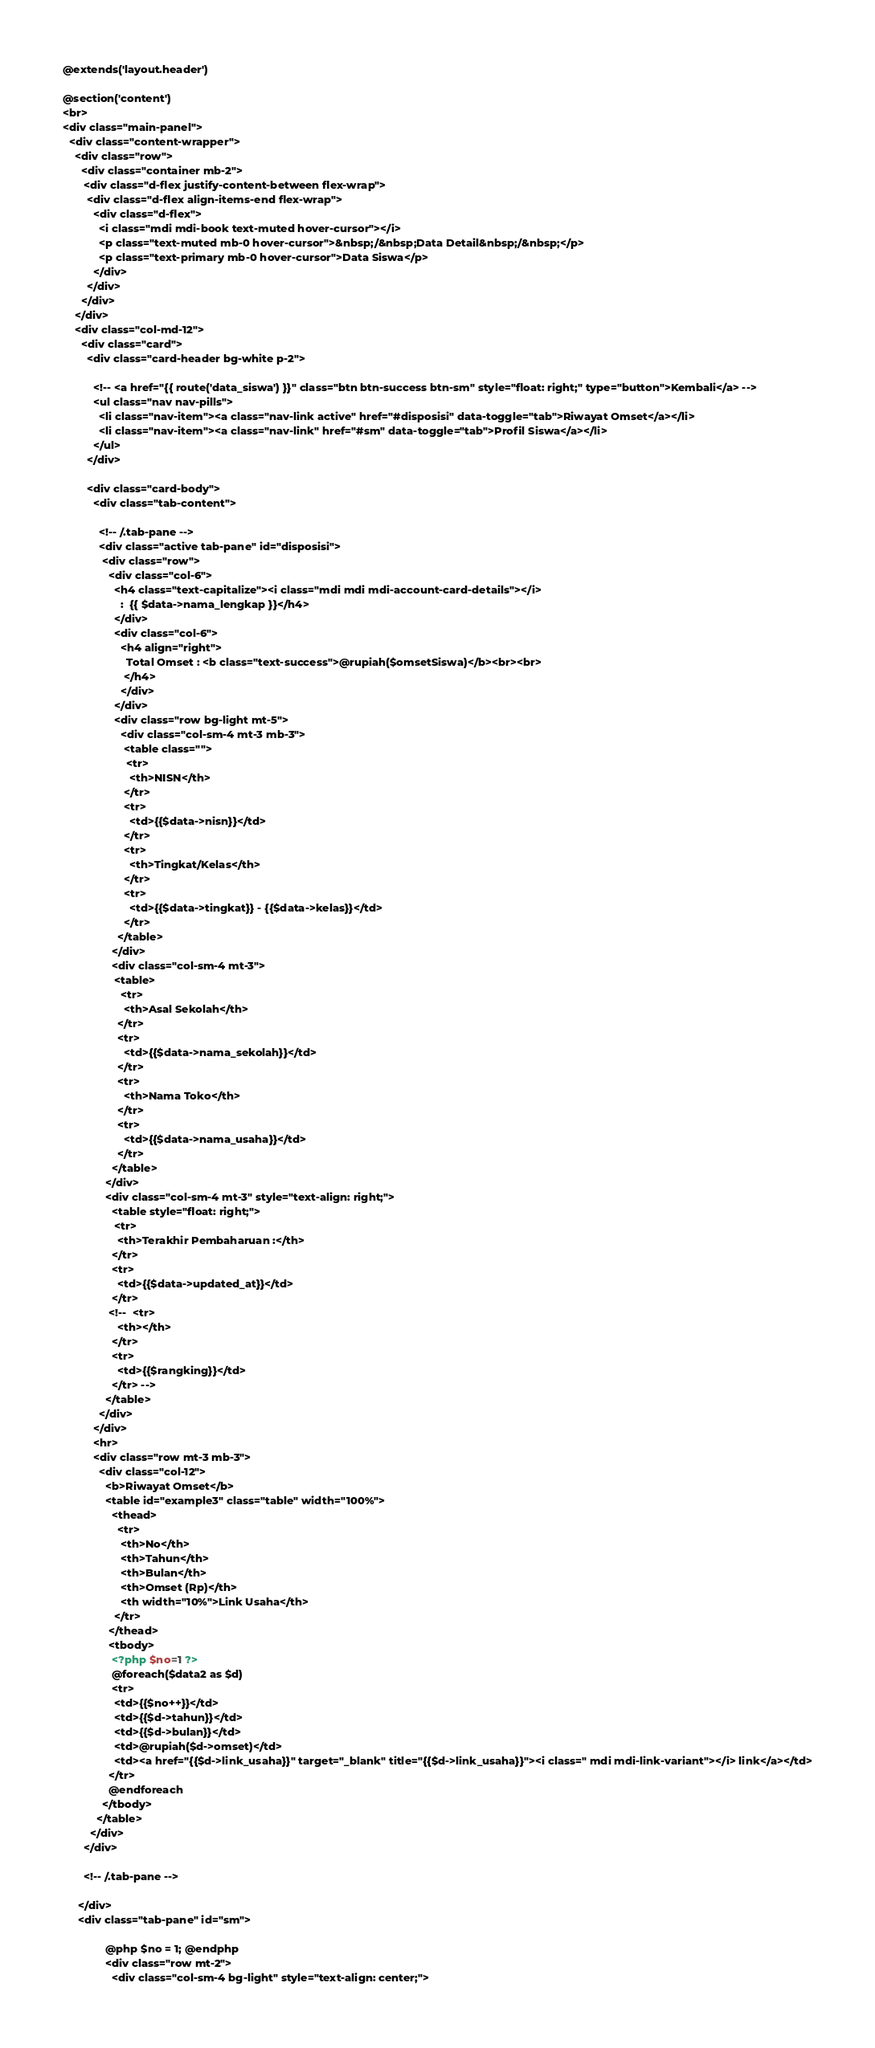Convert code to text. <code><loc_0><loc_0><loc_500><loc_500><_PHP_>@extends('layout.header')

@section('content')
<br>
<div class="main-panel">
  <div class="content-wrapper">
    <div class="row">
      <div class="container mb-2">
       <div class="d-flex justify-content-between flex-wrap">
        <div class="d-flex align-items-end flex-wrap">
          <div class="d-flex">
            <i class="mdi mdi-book text-muted hover-cursor"></i>
            <p class="text-muted mb-0 hover-cursor">&nbsp;/&nbsp;Data Detail&nbsp;/&nbsp;</p>
            <p class="text-primary mb-0 hover-cursor">Data Siswa</p>
          </div>
        </div>
      </div>
    </div>
    <div class="col-md-12">
      <div class="card">
        <div class="card-header bg-white p-2">

          <!-- <a href="{{ route('data_siswa') }}" class="btn btn-success btn-sm" style="float: right;" type="button">Kembali</a> -->
          <ul class="nav nav-pills">
            <li class="nav-item"><a class="nav-link active" href="#disposisi" data-toggle="tab">Riwayat Omset</a></li>
            <li class="nav-item"><a class="nav-link" href="#sm" data-toggle="tab">Profil Siswa</a></li>
          </ul>
        </div>

        <div class="card-body">
          <div class="tab-content">
            
            <!-- /.tab-pane -->
            <div class="active tab-pane" id="disposisi">
             <div class="row">
               <div class="col-6">
                 <h4 class="text-capitalize"><i class="mdi mdi mdi-account-card-details"></i>
                   :  {{ $data->nama_lengkap }}</h4>
                 </div>
                 <div class="col-6">
                   <h4 align="right">
                     Total Omset : <b class="text-success">@rupiah($omsetSiswa)</b><br><br>
                    </h4>
                   </div>
                 </div>
                 <div class="row bg-light mt-5">
                   <div class="col-sm-4 mt-3 mb-3">
                    <table class="">
                     <tr>
                      <th>NISN</th>
                    </tr>
                    <tr>
                      <td>{{$data->nisn}}</td>
                    </tr>
                    <tr>
                      <th>Tingkat/Kelas</th>
                    </tr>
                    <tr>
                      <td>{{$data->tingkat}} - {{$data->kelas}}</td>
                    </tr>
                  </table>
                </div>
                <div class="col-sm-4 mt-3">
                 <table>
                   <tr>
                    <th>Asal Sekolah</th>
                  </tr>
                  <tr>
                    <td>{{$data->nama_sekolah}}</td>
                  </tr>
                  <tr>
                    <th>Nama Toko</th>
                  </tr>
                  <tr>
                    <td>{{$data->nama_usaha}}</td>
                  </tr>
                </table>
              </div>
              <div class="col-sm-4 mt-3" style="text-align: right;"> 
                <table style="float: right;">
                 <tr>
                  <th>Terakhir Pembaharuan :</th>
                </tr>
                <tr>
                  <td>{{$data->updated_at}}</td>
                </tr>
               <!--  <tr>
                  <th></th>
                </tr>
                <tr>
                  <td>{{$rangking}}</td>
                </tr> -->
              </table>
            </div>
          </div>
          <hr>
          <div class="row mt-3 mb-3">
            <div class="col-12">
              <b>Riwayat Omset</b>
              <table id="example3" class="table" width="100%">
                <thead>
                  <tr>
                   <th>No</th>
                   <th>Tahun</th>
                   <th>Bulan</th>
                   <th>Omset (Rp)</th>
                   <th width="10%">Link Usaha</th>
                 </tr>
               </thead>
               <tbody>
                <?php $no=1 ?> 
                @foreach($data2 as $d)
                <tr>
                 <td>{{$no++}}</td>
                 <td>{{$d->tahun}}</td>
                 <td>{{$d->bulan}}</td>
                 <td>@rupiah($d->omset)</td>
                 <td><a href="{{$d->link_usaha}}" target="_blank" title="{{$d->link_usaha}}"><i class=" mdi mdi-link-variant"></i> link</a></td>
               </tr>
               @endforeach
             </tbody>
           </table>
         </div>
       </div>

       <!-- /.tab-pane -->

     </div> 
     <div class="tab-pane" id="sm">

              @php $no = 1; @endphp
              <div class="row mt-2">
                <div class="col-sm-4 bg-light" style="text-align: center;"></code> 